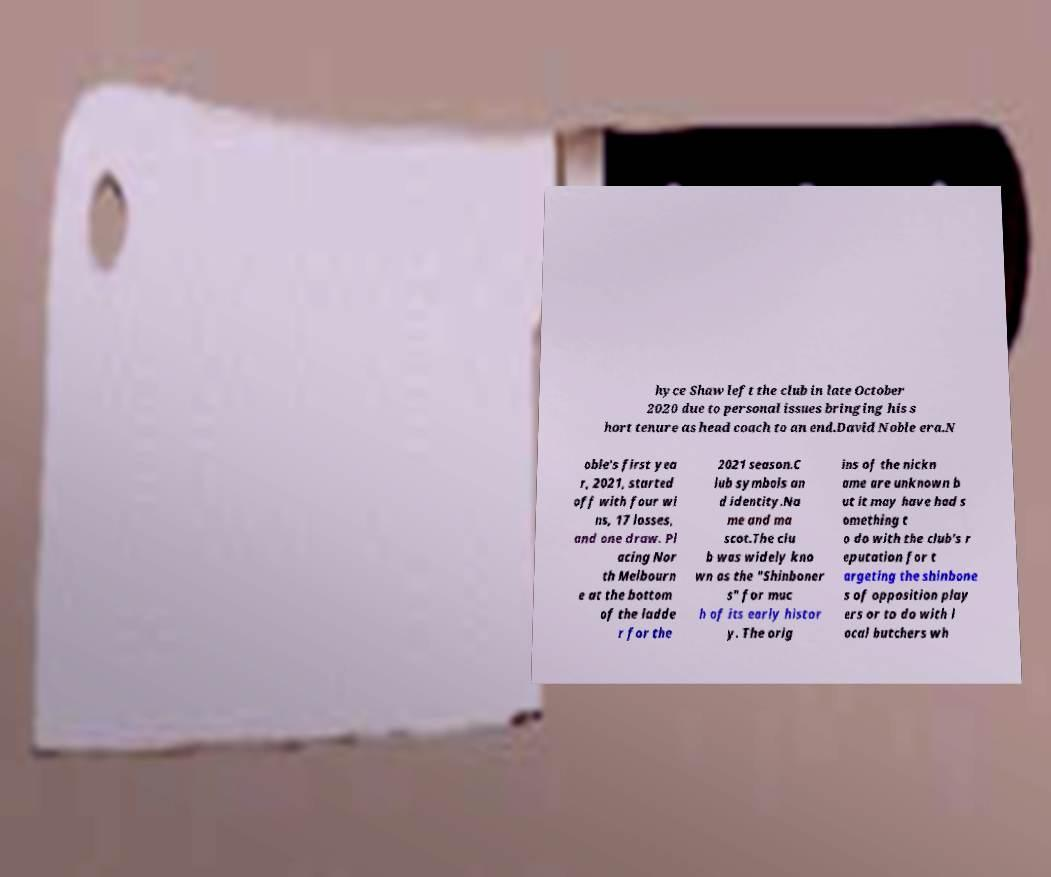What messages or text are displayed in this image? I need them in a readable, typed format. hyce Shaw left the club in late October 2020 due to personal issues bringing his s hort tenure as head coach to an end.David Noble era.N oble's first yea r, 2021, started off with four wi ns, 17 losses, and one draw. Pl acing Nor th Melbourn e at the bottom of the ladde r for the 2021 season.C lub symbols an d identity.Na me and ma scot.The clu b was widely kno wn as the "Shinboner s" for muc h of its early histor y. The orig ins of the nickn ame are unknown b ut it may have had s omething t o do with the club's r eputation for t argeting the shinbone s of opposition play ers or to do with l ocal butchers wh 